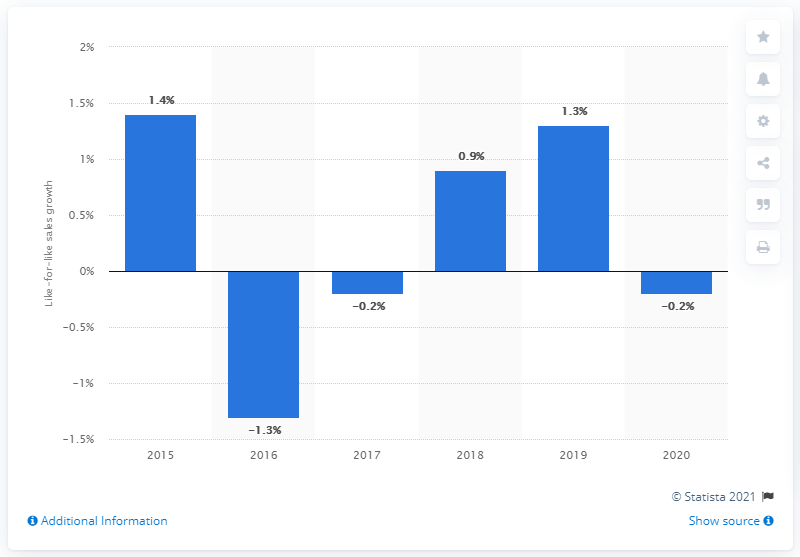Highlight a few significant elements in this photo. Waitrose's like-for-like sales growth in the year prior was 1.3%. 